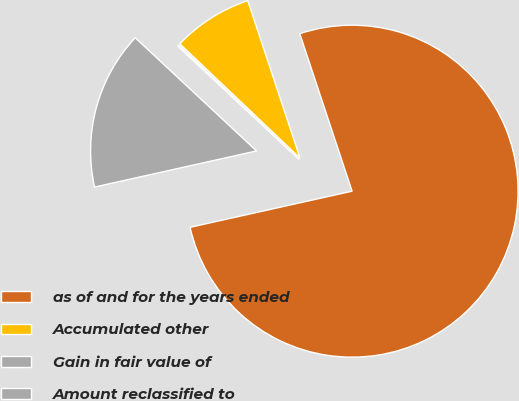Convert chart. <chart><loc_0><loc_0><loc_500><loc_500><pie_chart><fcel>as of and for the years ended<fcel>Accumulated other<fcel>Gain in fair value of<fcel>Amount reclassified to<nl><fcel>76.61%<fcel>7.8%<fcel>0.15%<fcel>15.44%<nl></chart> 